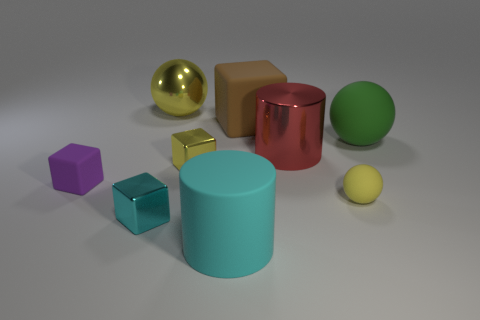Subtract all blocks. How many objects are left? 5 Add 7 large matte blocks. How many large matte blocks exist? 8 Subtract 0 green blocks. How many objects are left? 9 Subtract all small red metallic spheres. Subtract all brown objects. How many objects are left? 8 Add 2 shiny things. How many shiny things are left? 6 